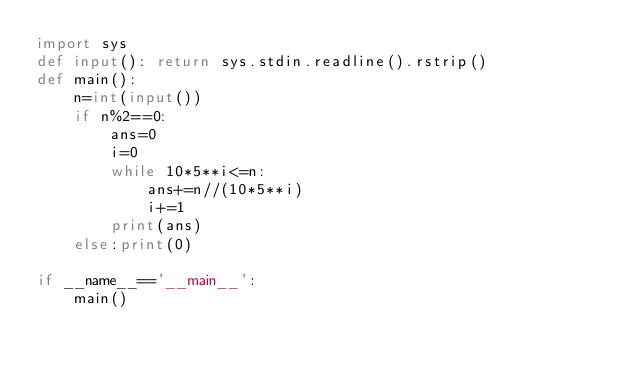Convert code to text. <code><loc_0><loc_0><loc_500><loc_500><_Python_>import sys
def input(): return sys.stdin.readline().rstrip()
def main():
    n=int(input())
    if n%2==0:
        ans=0
        i=0
        while 10*5**i<=n:
            ans+=n//(10*5**i)
            i+=1
        print(ans)
    else:print(0)

if __name__=='__main__':
    main()</code> 